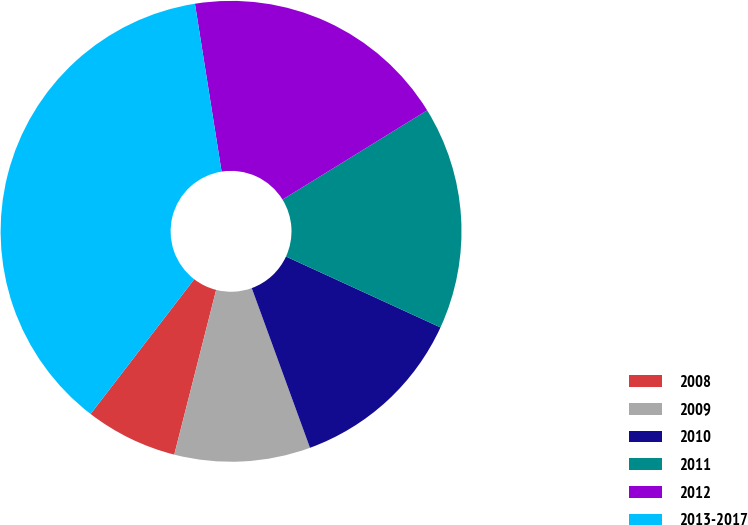Convert chart. <chart><loc_0><loc_0><loc_500><loc_500><pie_chart><fcel>2008<fcel>2009<fcel>2010<fcel>2011<fcel>2012<fcel>2013-2017<nl><fcel>6.47%<fcel>9.53%<fcel>12.59%<fcel>15.65%<fcel>18.71%<fcel>37.07%<nl></chart> 